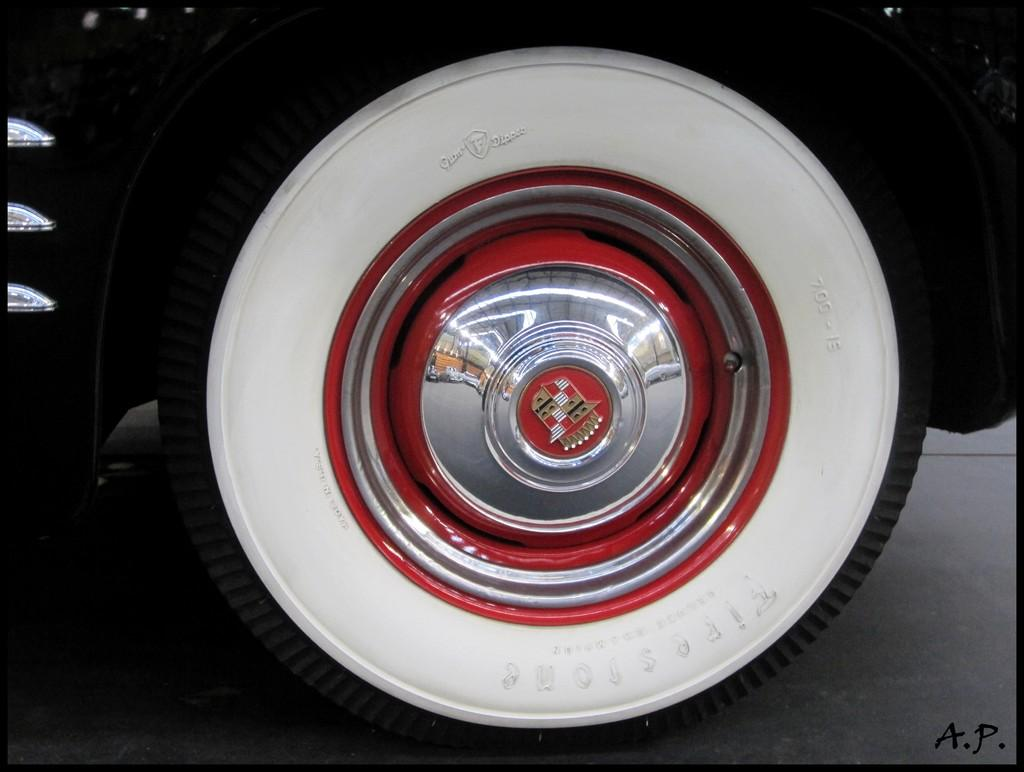What is the main subject of the image? The main subject of the image is a color wheel. Can you describe the color wheel in the image? The color wheel in the image has red, silver, and white colors. What else is present in the image besides the color wheel? There is a black color vehicle in the image. What type of good-bye message is written on the stage in the image? There is no stage present in the image, and therefore no good-bye message can be observed. Is it raining in the image? The image does not provide any information about the weather, so it cannot be determined if it is raining. 